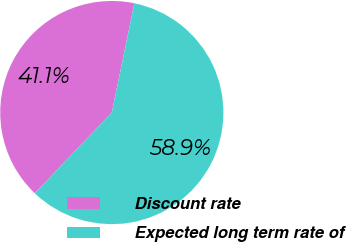Convert chart to OTSL. <chart><loc_0><loc_0><loc_500><loc_500><pie_chart><fcel>Discount rate<fcel>Expected long term rate of<nl><fcel>41.11%<fcel>58.89%<nl></chart> 